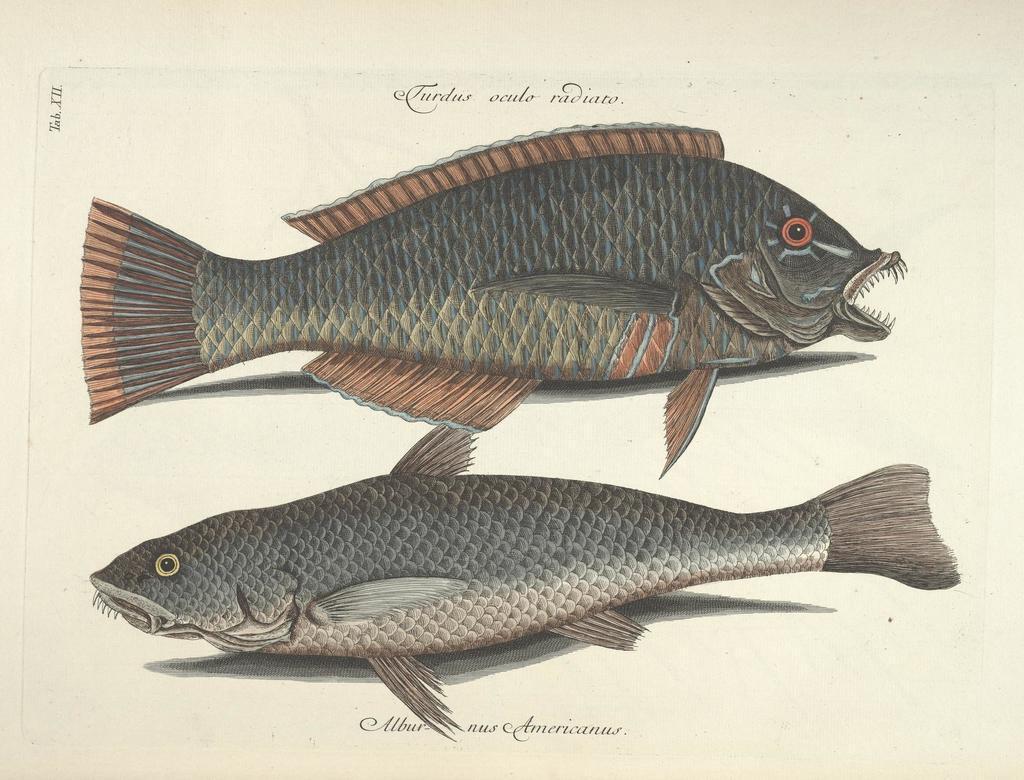How would you summarize this image in a sentence or two? In this picture we can see art of fishes, and we can find some text. 